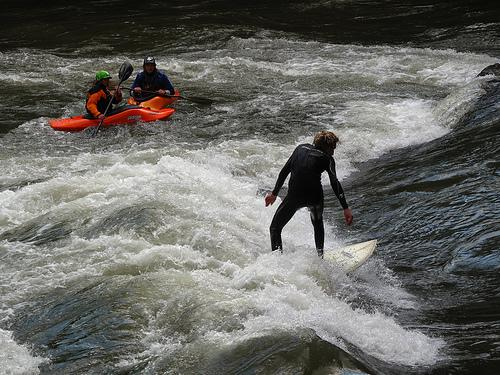Question: what color are the boats?
Choices:
A. Black.
B. Red.
C. White.
D. Orange.
Answer with the letter. Answer: D Question: who is in the boats?
Choices:
A. Three people.
B. Man and a woman.
C. The rest of your friends.
D. Jan and Stan.
Answer with the letter. Answer: B Question: where was the photo taken?
Choices:
A. The lake.
B. The beach.
C. The river.
D. The mountains.
Answer with the letter. Answer: C 